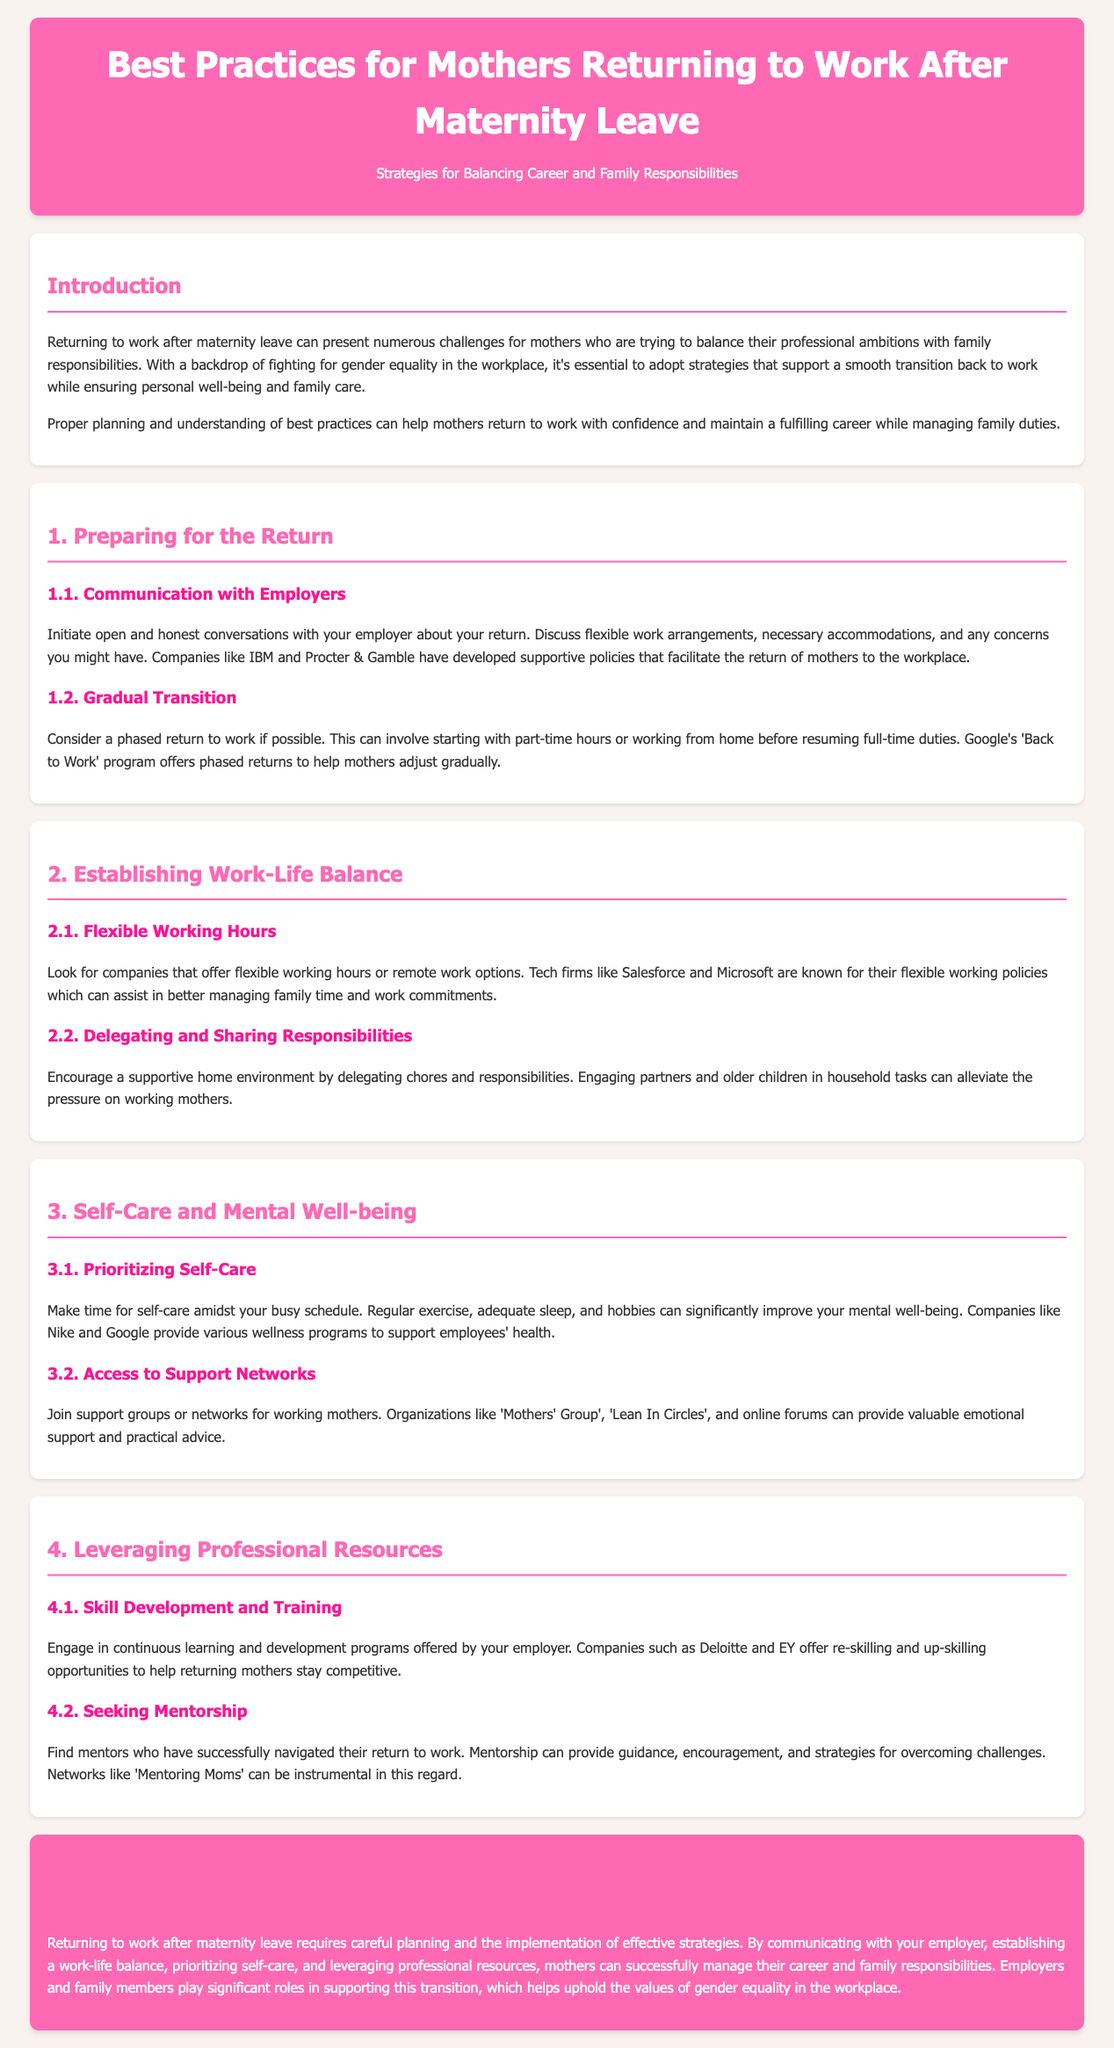What is the title of the document? The title indicates what the document is about and is shown prominently at the top.
Answer: Best Practices for Mothers Returning to Work After Maternity Leave What program does Google offer for phased returns? This program is specifically mentioned in the document as a support for mothers returning to work.
Answer: Back to Work Which companies provide wellness programs to support employees' health? These companies are cited as examples that facilitate self-care and mental well-being.
Answer: Nike and Google What is a suggested strategy for establishing work-life balance? This refers to one of the recommended practices for managing commitments at work and home.
Answer: Flexible Working Hours Which organization can provide valuable emotional support and practical advice? This organization is specifically mentioned as a resource for working mothers.
Answer: Mothers' Group In which section is "Skill Development and Training" discussed? This section is about leveraging professional resources, communicating the importance of continuous learning.
Answer: 4 Name a company known for its flexible working policies. Companies are mentioned in relation to work arrangements that assist working mothers.
Answer: Salesforce What should mothers prioritize for their mental well-being? This aspect is emphasized in the document related to self-care strategies.
Answer: Self-Care 